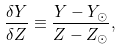Convert formula to latex. <formula><loc_0><loc_0><loc_500><loc_500>\frac { \delta Y } { \delta Z } \equiv \frac { Y - Y _ { \odot } } { Z - Z _ { \odot } } ,</formula> 